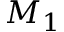Convert formula to latex. <formula><loc_0><loc_0><loc_500><loc_500>M _ { 1 }</formula> 